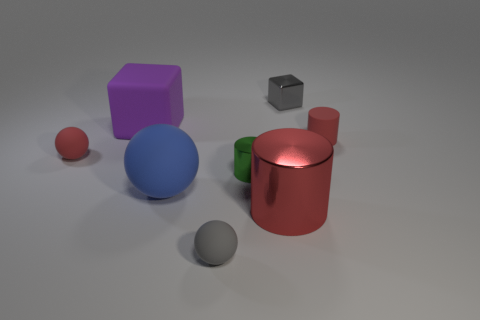Add 1 small metal blocks. How many objects exist? 9 Subtract all cubes. How many objects are left? 6 Subtract all small cyan metal balls. Subtract all small gray balls. How many objects are left? 7 Add 6 large purple objects. How many large purple objects are left? 7 Add 2 purple matte cylinders. How many purple matte cylinders exist? 2 Subtract 1 green cylinders. How many objects are left? 7 